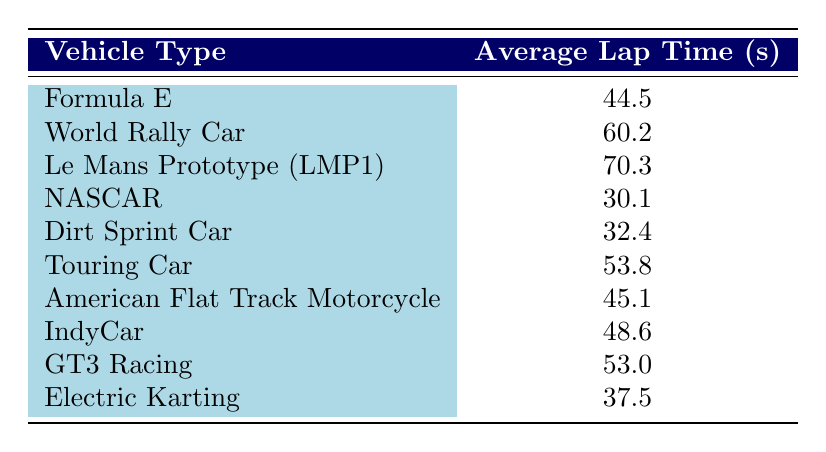What is the average lap time for NASCAR? The table provides a specific value for NASCAR's average lap time, which is listed directly next to the vehicle type. It shows 30.1 seconds as the average lap time for NASCAR.
Answer: 30.1 seconds Which vehicle type has the longest average lap time? By reviewing each vehicle's average lap time in the table, Le Mans Prototype (LMP1) has the highest value at 70.3 seconds, making it the longest.
Answer: Le Mans Prototype (LMP1) What is the difference in average lap times between Electric Karting and Dirt Sprint Car? To find the difference, we subtract the average lap time of Electric Karting (37.5 seconds) from that of Dirt Sprint Car (32.4 seconds). The calculation is 37.5 - 32.4 = 5.1 seconds.
Answer: 5.1 seconds Is the average lap time for Touring Car less than that of Formula E? Comparing the average lap times from the table, Touring Car has an average lap time of 53.8 seconds, while Formula E's is 44.5 seconds. Since 53.8 is greater than 44.5, the statement is false.
Answer: No What is the average lap time of all vehicles listed in the table? To find the average, we sum the average lap times (44.5 + 60.2 + 70.3 + 30.1 + 32.4 + 53.8 + 45.1 + 48.6 + 53.0 + 37.5 =  454.5 seconds) and divide by the number of vehicle types (10). Therefore, the average lap time is 454.5 / 10 = 45.45 seconds.
Answer: 45.45 seconds Which vehicle types have average lap times below 40 seconds? By scanning the table, Electric Karting (37.5 seconds) and NASCAR (30.1 seconds) both have average lap times below 40 seconds. Therefore, the answer includes these two vehicle types.
Answer: Electric Karting and NASCAR What is the median average lap time among the vehicle types listed? To find the median, we first list the average lap times in ascending order: 30.1, 32.4, 37.5, 44.5, 45.1, 48.6, 53.0, 53.8, 60.2, 70.3. Since there are 10 values (even number), the median is found by taking the average of the two middle values (45.1 and 48.6), thus (45.1 + 48.6) / 2 = 46.85 seconds.
Answer: 46.85 seconds Is American Flat Track Motorcycle average lap time the second shortest among the vehicles? Reviewing the average lap times, NASCAR (30.1 seconds) has the shortest, followed by Dirt Sprint Car (32.4 seconds), and American Flat Track Motorcycle (45.1 seconds). Therefore, American Flat Track Motorcycle does not have the second shortest lap time; it ranks third.
Answer: No 